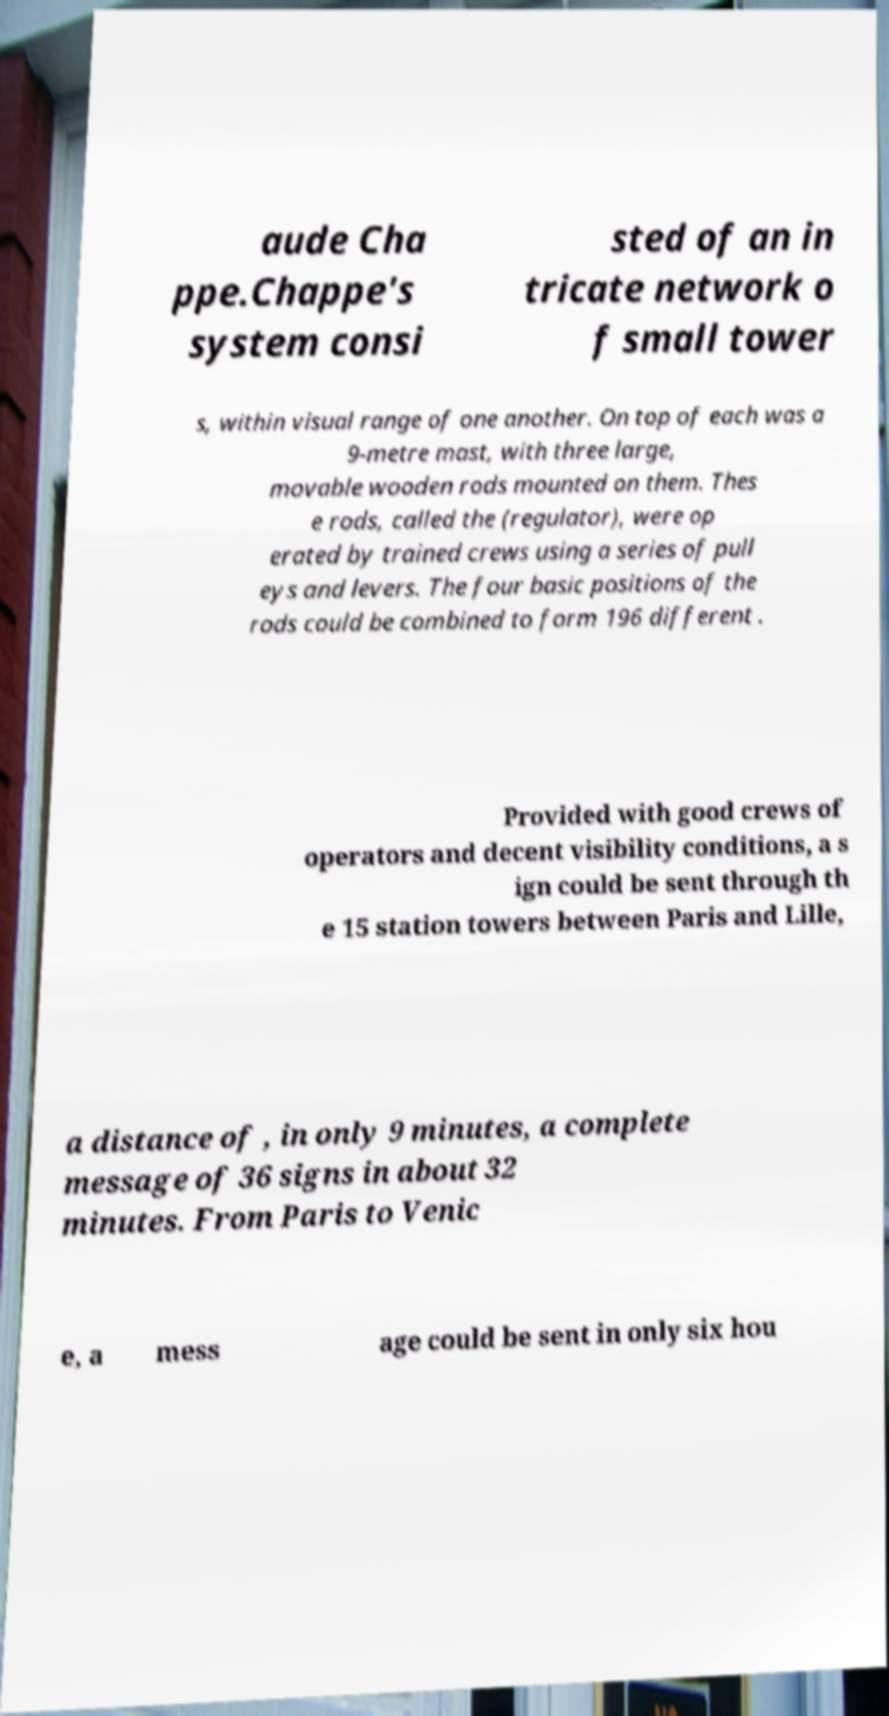For documentation purposes, I need the text within this image transcribed. Could you provide that? aude Cha ppe.Chappe's system consi sted of an in tricate network o f small tower s, within visual range of one another. On top of each was a 9-metre mast, with three large, movable wooden rods mounted on them. Thes e rods, called the (regulator), were op erated by trained crews using a series of pull eys and levers. The four basic positions of the rods could be combined to form 196 different . Provided with good crews of operators and decent visibility conditions, a s ign could be sent through th e 15 station towers between Paris and Lille, a distance of , in only 9 minutes, a complete message of 36 signs in about 32 minutes. From Paris to Venic e, a mess age could be sent in only six hou 